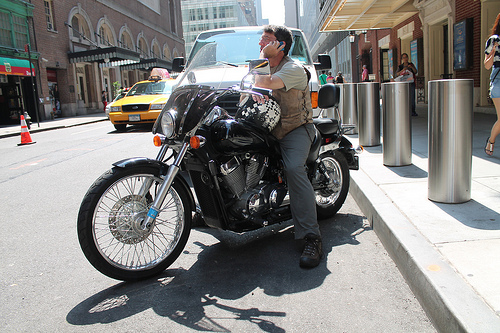Is the cab to the left or to the right of the man that is to the left of the people? The cab is to the left of the man who is leaning on the motorcycle, and this man is to the left of the pedestrians on the sidewalk. 